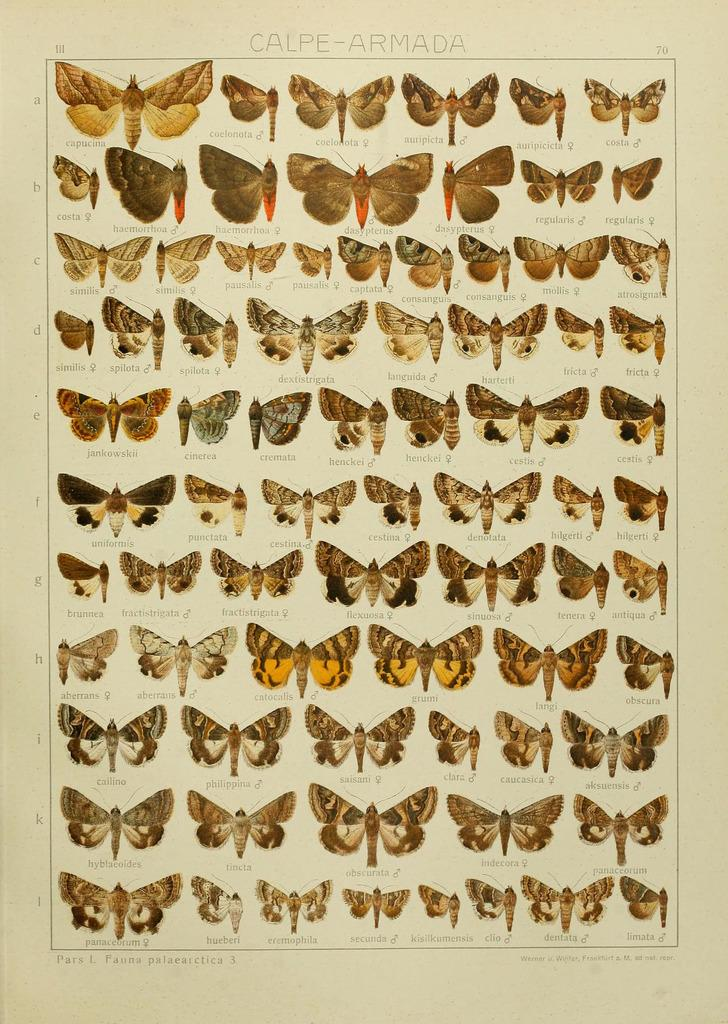What is present in the image? There is a poster in the image. What is depicted on the poster? The poster contains many butterflies. What type of education system is being discussed in the image? There is no discussion of an education system in the image; it only contains a poster with butterflies. What role does the rod play in the image? There is no rod present in the image. 